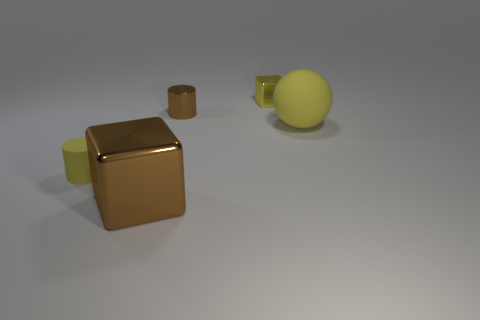Subtract all brown cylinders. How many cylinders are left? 1 Subtract all cubes. How many objects are left? 3 Add 3 large matte things. How many objects exist? 8 Add 3 blue shiny cylinders. How many blue shiny cylinders exist? 3 Subtract 0 gray spheres. How many objects are left? 5 Subtract 1 cubes. How many cubes are left? 1 Subtract all brown blocks. Subtract all blue cylinders. How many blocks are left? 1 Subtract all blue spheres. How many brown blocks are left? 1 Subtract all small rubber things. Subtract all small purple metallic objects. How many objects are left? 4 Add 5 big things. How many big things are left? 7 